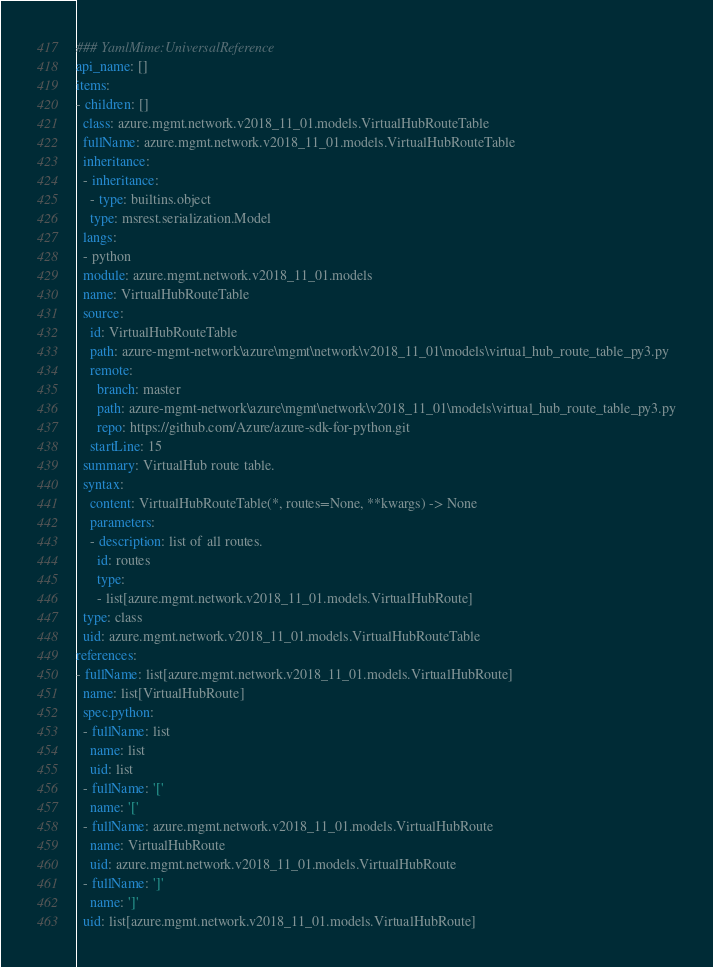Convert code to text. <code><loc_0><loc_0><loc_500><loc_500><_YAML_>### YamlMime:UniversalReference
api_name: []
items:
- children: []
  class: azure.mgmt.network.v2018_11_01.models.VirtualHubRouteTable
  fullName: azure.mgmt.network.v2018_11_01.models.VirtualHubRouteTable
  inheritance:
  - inheritance:
    - type: builtins.object
    type: msrest.serialization.Model
  langs:
  - python
  module: azure.mgmt.network.v2018_11_01.models
  name: VirtualHubRouteTable
  source:
    id: VirtualHubRouteTable
    path: azure-mgmt-network\azure\mgmt\network\v2018_11_01\models\virtual_hub_route_table_py3.py
    remote:
      branch: master
      path: azure-mgmt-network\azure\mgmt\network\v2018_11_01\models\virtual_hub_route_table_py3.py
      repo: https://github.com/Azure/azure-sdk-for-python.git
    startLine: 15
  summary: VirtualHub route table.
  syntax:
    content: VirtualHubRouteTable(*, routes=None, **kwargs) -> None
    parameters:
    - description: list of all routes.
      id: routes
      type:
      - list[azure.mgmt.network.v2018_11_01.models.VirtualHubRoute]
  type: class
  uid: azure.mgmt.network.v2018_11_01.models.VirtualHubRouteTable
references:
- fullName: list[azure.mgmt.network.v2018_11_01.models.VirtualHubRoute]
  name: list[VirtualHubRoute]
  spec.python:
  - fullName: list
    name: list
    uid: list
  - fullName: '['
    name: '['
  - fullName: azure.mgmt.network.v2018_11_01.models.VirtualHubRoute
    name: VirtualHubRoute
    uid: azure.mgmt.network.v2018_11_01.models.VirtualHubRoute
  - fullName: ']'
    name: ']'
  uid: list[azure.mgmt.network.v2018_11_01.models.VirtualHubRoute]
</code> 